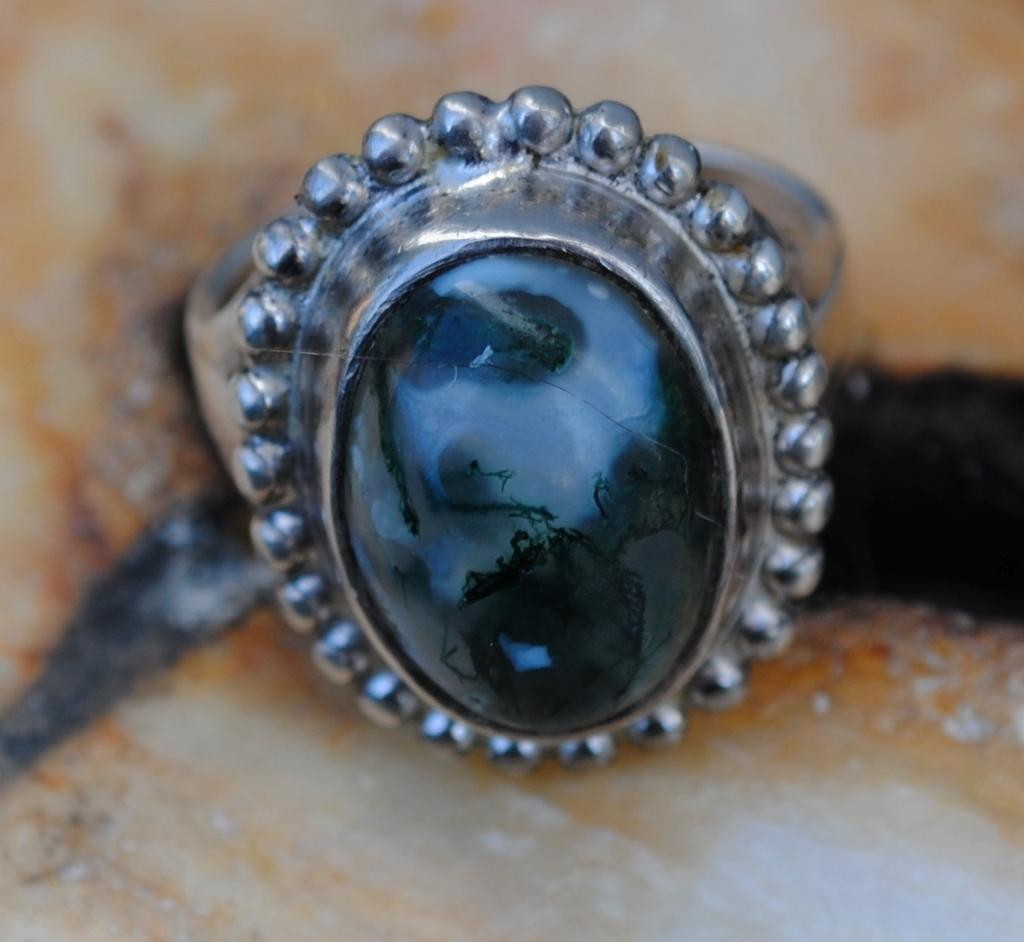What is the main subject of the image? The main subject of the image is a ring. What is the color of the stone in the ring? The stone in the ring has a black color. What is the stone placed on top of in the image? The stone is placed on top of an object in the image. What type of lawyer is depicted in the image? There is no lawyer present in the image; it features a ring with a black stone. How many units are visible in the image? There is no reference to units in the image; it only shows a ring with a black stone. 